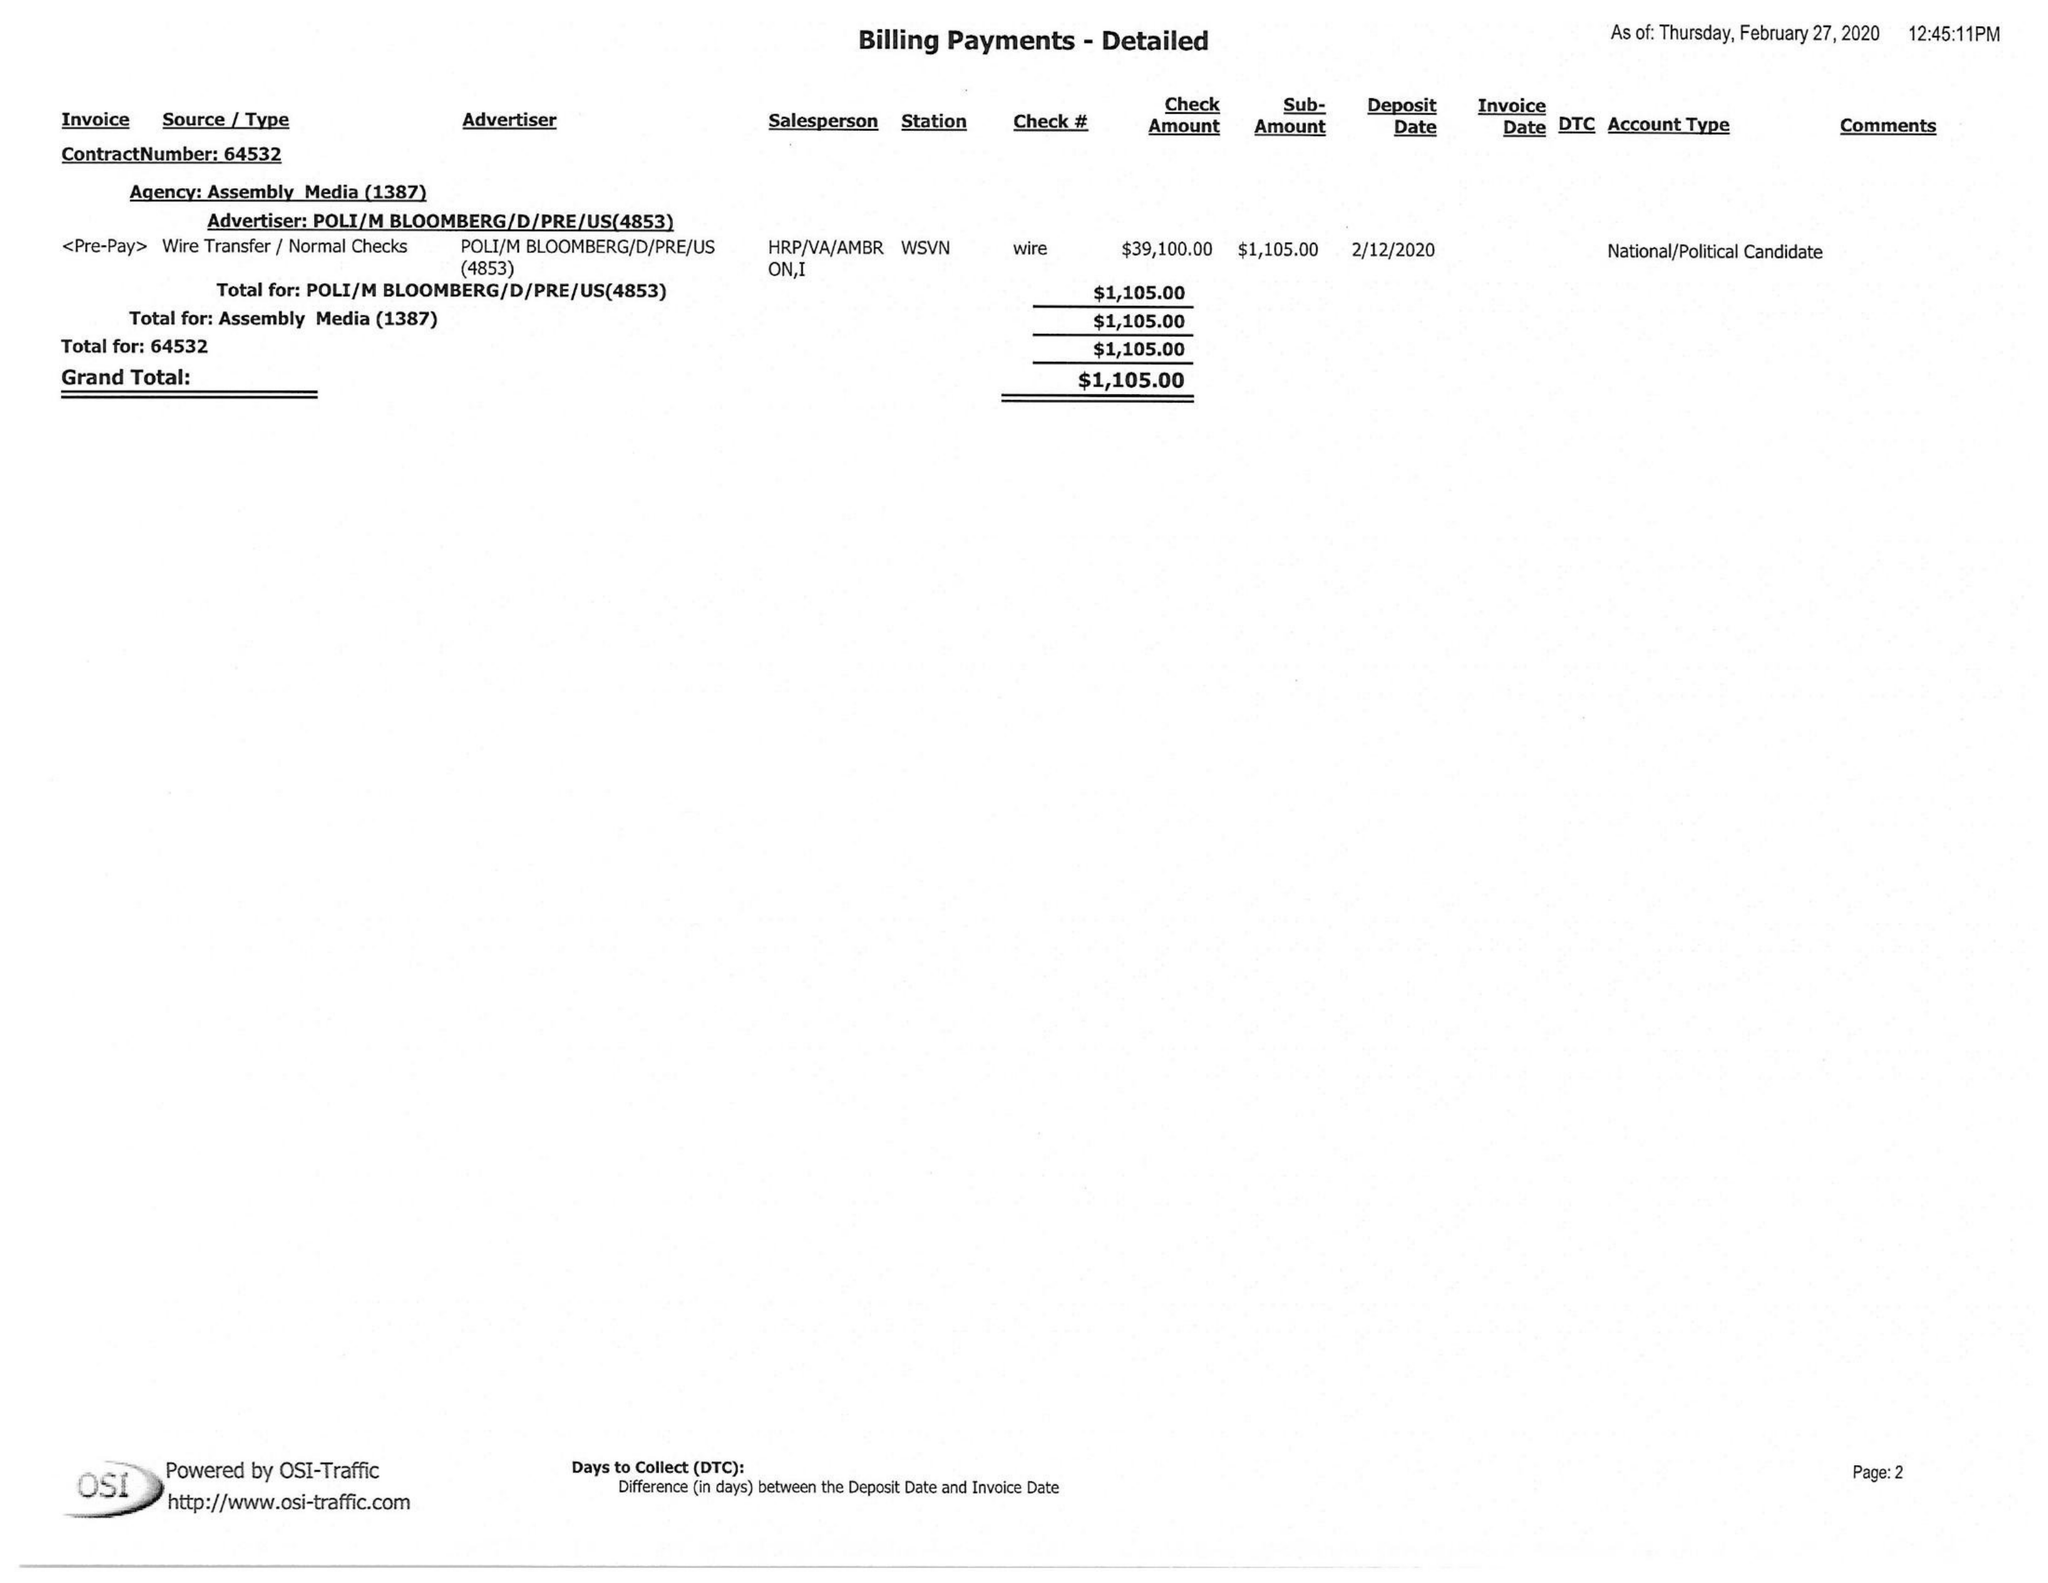What is the value for the gross_amount?
Answer the question using a single word or phrase. 1105.00 